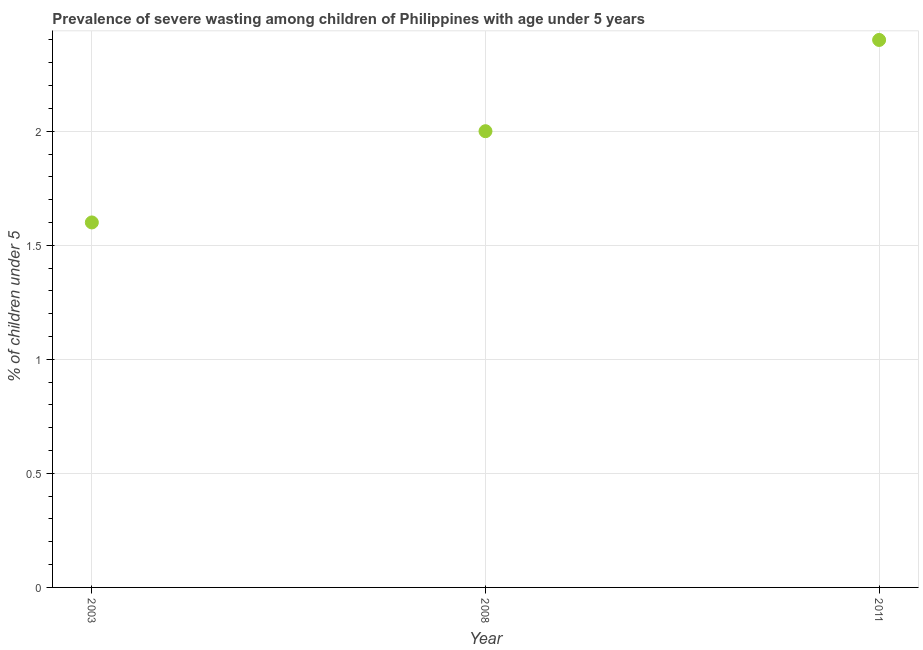What is the prevalence of severe wasting in 2003?
Offer a very short reply. 1.6. Across all years, what is the maximum prevalence of severe wasting?
Your answer should be compact. 2.4. Across all years, what is the minimum prevalence of severe wasting?
Provide a succinct answer. 1.6. In which year was the prevalence of severe wasting minimum?
Keep it short and to the point. 2003. What is the sum of the prevalence of severe wasting?
Ensure brevity in your answer.  6. What is the difference between the prevalence of severe wasting in 2003 and 2011?
Give a very brief answer. -0.8. What is the average prevalence of severe wasting per year?
Make the answer very short. 2. Do a majority of the years between 2011 and 2008 (inclusive) have prevalence of severe wasting greater than 1.8 %?
Your answer should be compact. No. What is the ratio of the prevalence of severe wasting in 2003 to that in 2008?
Ensure brevity in your answer.  0.8. Is the difference between the prevalence of severe wasting in 2003 and 2011 greater than the difference between any two years?
Provide a succinct answer. Yes. What is the difference between the highest and the second highest prevalence of severe wasting?
Give a very brief answer. 0.4. What is the difference between the highest and the lowest prevalence of severe wasting?
Your answer should be compact. 0.8. How many dotlines are there?
Provide a succinct answer. 1. How many years are there in the graph?
Offer a terse response. 3. What is the difference between two consecutive major ticks on the Y-axis?
Provide a succinct answer. 0.5. Are the values on the major ticks of Y-axis written in scientific E-notation?
Your response must be concise. No. Does the graph contain grids?
Offer a very short reply. Yes. What is the title of the graph?
Ensure brevity in your answer.  Prevalence of severe wasting among children of Philippines with age under 5 years. What is the label or title of the Y-axis?
Give a very brief answer.  % of children under 5. What is the  % of children under 5 in 2003?
Your response must be concise. 1.6. What is the  % of children under 5 in 2008?
Ensure brevity in your answer.  2. What is the  % of children under 5 in 2011?
Offer a terse response. 2.4. What is the difference between the  % of children under 5 in 2003 and 2008?
Give a very brief answer. -0.4. What is the difference between the  % of children under 5 in 2003 and 2011?
Your answer should be very brief. -0.8. What is the ratio of the  % of children under 5 in 2003 to that in 2011?
Offer a very short reply. 0.67. What is the ratio of the  % of children under 5 in 2008 to that in 2011?
Offer a terse response. 0.83. 